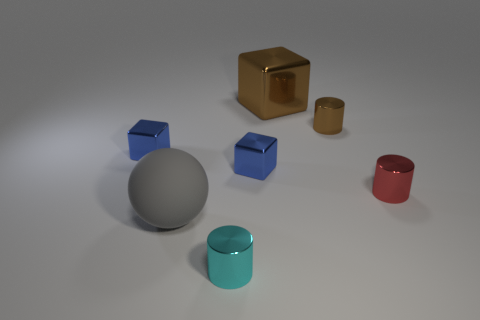Are the small cylinder left of the big block and the block left of the large ball made of the same material?
Ensure brevity in your answer.  Yes. What material is the small cylinder that is the same color as the big metal cube?
Your answer should be compact. Metal. What is the shape of the object that is right of the large brown object and in front of the brown metallic cylinder?
Your response must be concise. Cylinder. What is the material of the large thing that is in front of the brown object that is in front of the brown metallic block?
Provide a short and direct response. Rubber. Are there more metal things than things?
Provide a short and direct response. No. There is a red thing that is the same size as the cyan thing; what is it made of?
Offer a terse response. Metal. Is the material of the red object the same as the brown cylinder?
Your response must be concise. Yes. What number of tiny cubes are the same material as the red cylinder?
Offer a very short reply. 2. What number of things are either tiny blocks that are on the left side of the cyan metal object or tiny cubes to the left of the tiny cyan metal cylinder?
Offer a very short reply. 1. Is the number of blue metal things that are on the left side of the brown cube greater than the number of tiny cyan metallic cylinders that are right of the red cylinder?
Your response must be concise. Yes. 